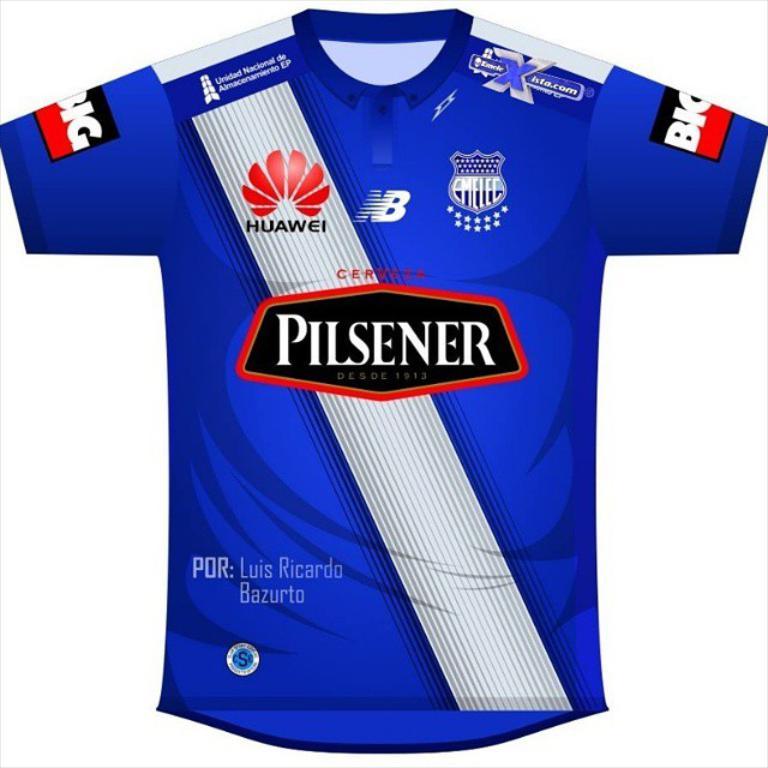Does huawei sponsor this jersey?
Your answer should be very brief. Yes. 